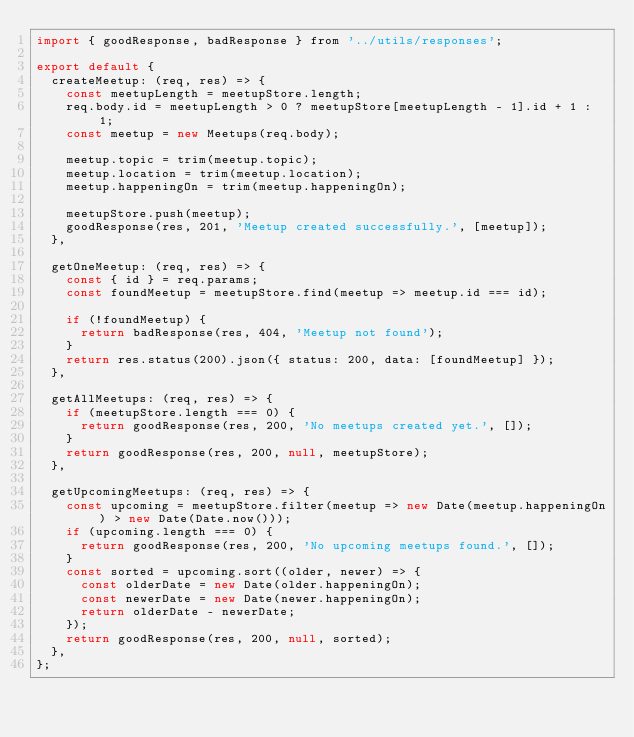Convert code to text. <code><loc_0><loc_0><loc_500><loc_500><_JavaScript_>import { goodResponse, badResponse } from '../utils/responses';

export default {
  createMeetup: (req, res) => {
    const meetupLength = meetupStore.length;
    req.body.id = meetupLength > 0 ? meetupStore[meetupLength - 1].id + 1 : 1;
    const meetup = new Meetups(req.body);

    meetup.topic = trim(meetup.topic);
    meetup.location = trim(meetup.location);
    meetup.happeningOn = trim(meetup.happeningOn);

    meetupStore.push(meetup);
    goodResponse(res, 201, 'Meetup created successfully.', [meetup]);
  },

  getOneMeetup: (req, res) => {
    const { id } = req.params;
    const foundMeetup = meetupStore.find(meetup => meetup.id === id);

    if (!foundMeetup) {
      return badResponse(res, 404, 'Meetup not found');
    }
    return res.status(200).json({ status: 200, data: [foundMeetup] });
  },

  getAllMeetups: (req, res) => {
    if (meetupStore.length === 0) {
      return goodResponse(res, 200, 'No meetups created yet.', []);
    }
    return goodResponse(res, 200, null, meetupStore);
  },

  getUpcomingMeetups: (req, res) => {
    const upcoming = meetupStore.filter(meetup => new Date(meetup.happeningOn) > new Date(Date.now()));
    if (upcoming.length === 0) {
      return goodResponse(res, 200, 'No upcoming meetups found.', []);
    }
    const sorted = upcoming.sort((older, newer) => {
      const olderDate = new Date(older.happeningOn);
      const newerDate = new Date(newer.happeningOn);
      return olderDate - newerDate;
    });
    return goodResponse(res, 200, null, sorted);
  },
};
</code> 